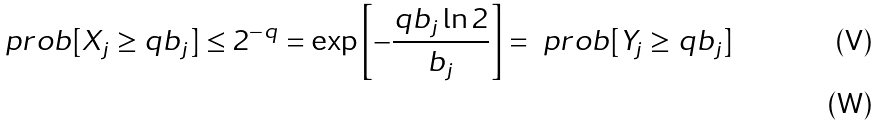<formula> <loc_0><loc_0><loc_500><loc_500>\ p r o b [ X _ { j } \geq q b _ { j } ] \leq 2 ^ { - q } = \exp \left [ - \frac { q b _ { j } \ln 2 } { b _ { j } } \right ] = \ p r o b [ Y _ { j } \geq q b _ { j } ] \\</formula> 